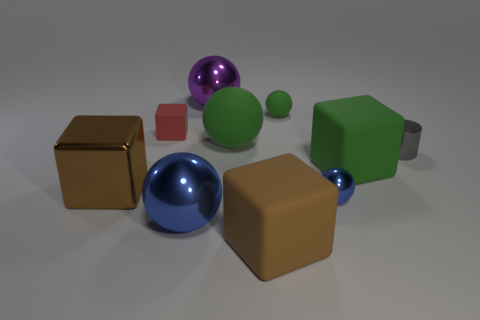Is there any other thing that is the same size as the purple sphere?
Ensure brevity in your answer.  Yes. Do the brown rubber cube and the shiny cylinder have the same size?
Ensure brevity in your answer.  No. There is a big metallic ball behind the brown metallic block; are there any small objects behind it?
Your response must be concise. No. What size is the rubber thing that is the same color as the metal cube?
Your answer should be very brief. Large. There is a purple metallic object that is to the left of the big brown rubber thing; what shape is it?
Provide a succinct answer. Sphere. There is a metallic ball behind the block to the right of the large brown rubber thing; how many small things are behind it?
Give a very brief answer. 0. There is a green block; is its size the same as the metal sphere that is to the right of the large purple thing?
Offer a terse response. No. What size is the blue shiny object that is to the left of the metal sphere that is behind the brown metal object?
Offer a terse response. Large. What number of gray cylinders are the same material as the small cube?
Give a very brief answer. 0. Are there any cyan things?
Your answer should be compact. No. 